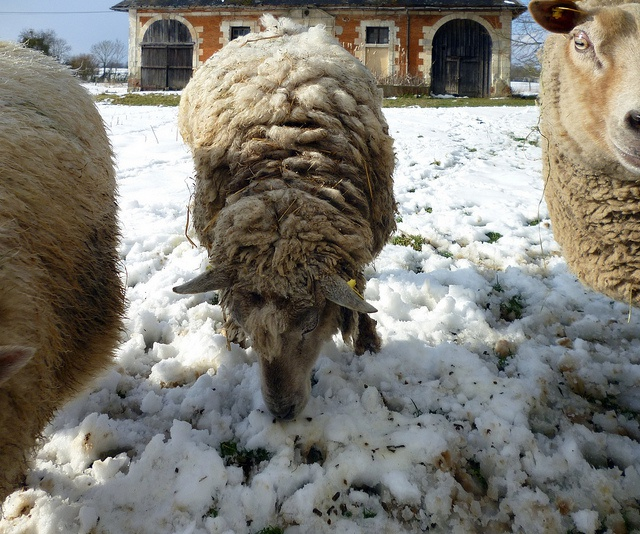Describe the objects in this image and their specific colors. I can see sheep in lightblue, black, and gray tones, sheep in lightblue, black, and gray tones, and sheep in lightblue, tan, and gray tones in this image. 